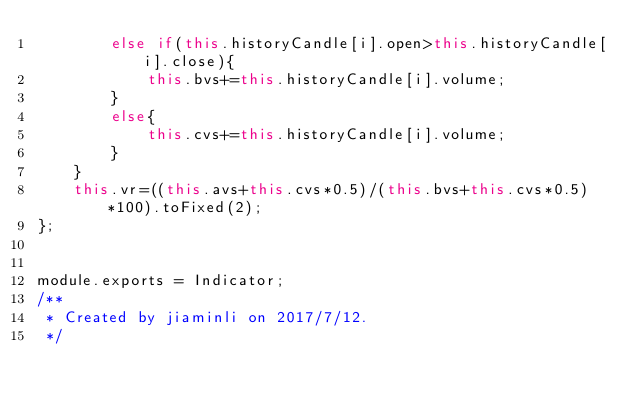Convert code to text. <code><loc_0><loc_0><loc_500><loc_500><_JavaScript_>        else if(this.historyCandle[i].open>this.historyCandle[i].close){
            this.bvs+=this.historyCandle[i].volume;
        }
        else{
            this.cvs+=this.historyCandle[i].volume;
        }
    }
    this.vr=((this.avs+this.cvs*0.5)/(this.bvs+this.cvs*0.5)*100).toFixed(2);
};


module.exports = Indicator;
/**
 * Created by jiaminli on 2017/7/12.
 */

</code> 